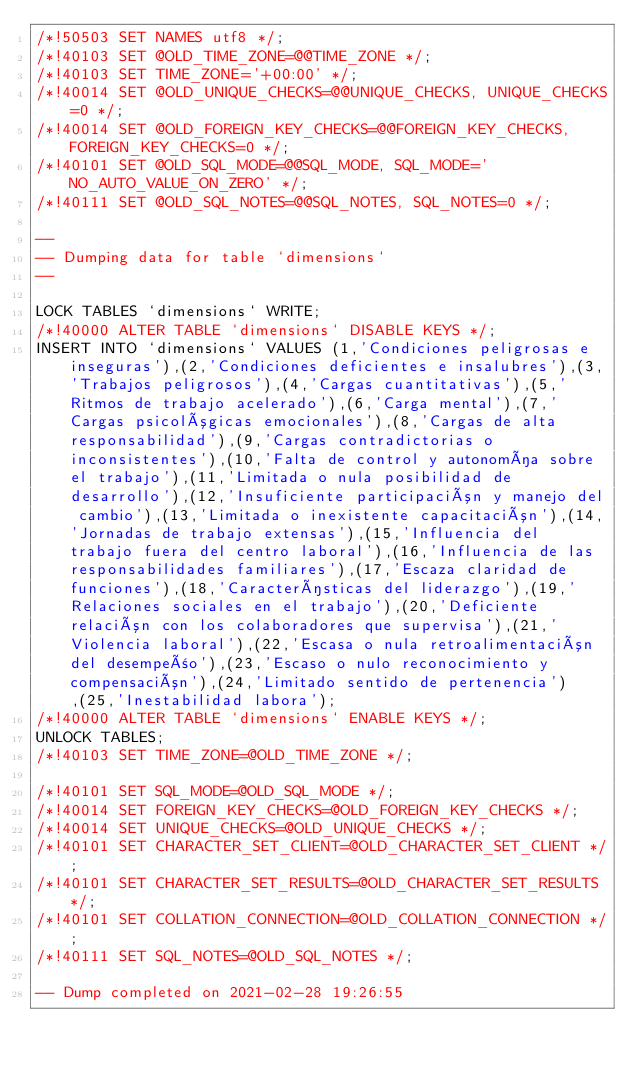<code> <loc_0><loc_0><loc_500><loc_500><_SQL_>/*!50503 SET NAMES utf8 */;
/*!40103 SET @OLD_TIME_ZONE=@@TIME_ZONE */;
/*!40103 SET TIME_ZONE='+00:00' */;
/*!40014 SET @OLD_UNIQUE_CHECKS=@@UNIQUE_CHECKS, UNIQUE_CHECKS=0 */;
/*!40014 SET @OLD_FOREIGN_KEY_CHECKS=@@FOREIGN_KEY_CHECKS, FOREIGN_KEY_CHECKS=0 */;
/*!40101 SET @OLD_SQL_MODE=@@SQL_MODE, SQL_MODE='NO_AUTO_VALUE_ON_ZERO' */;
/*!40111 SET @OLD_SQL_NOTES=@@SQL_NOTES, SQL_NOTES=0 */;

--
-- Dumping data for table `dimensions`
--

LOCK TABLES `dimensions` WRITE;
/*!40000 ALTER TABLE `dimensions` DISABLE KEYS */;
INSERT INTO `dimensions` VALUES (1,'Condiciones peligrosas e inseguras'),(2,'Condiciones deficientes e insalubres'),(3,'Trabajos peligrosos'),(4,'Cargas cuantitativas'),(5,'Ritmos de trabajo acelerado'),(6,'Carga mental'),(7,'Cargas psicológicas emocionales'),(8,'Cargas de alta responsabilidad'),(9,'Cargas contradictorias o inconsistentes'),(10,'Falta de control y autonomía sobre el trabajo'),(11,'Limitada o nula posibilidad de desarrollo'),(12,'Insuficiente participación y manejo del cambio'),(13,'Limitada o inexistente capacitación'),(14,'Jornadas de trabajo extensas'),(15,'Influencia del trabajo fuera del centro laboral'),(16,'Influencia de las responsabilidades familiares'),(17,'Escaza claridad de funciones'),(18,'Características del liderazgo'),(19,'Relaciones sociales en el trabajo'),(20,'Deficiente relación con los colaboradores que supervisa'),(21,'Violencia laboral'),(22,'Escasa o nula retroalimentación del desempeño'),(23,'Escaso o nulo reconocimiento y compensación'),(24,'Limitado sentido de pertenencia'),(25,'Inestabilidad labora');
/*!40000 ALTER TABLE `dimensions` ENABLE KEYS */;
UNLOCK TABLES;
/*!40103 SET TIME_ZONE=@OLD_TIME_ZONE */;

/*!40101 SET SQL_MODE=@OLD_SQL_MODE */;
/*!40014 SET FOREIGN_KEY_CHECKS=@OLD_FOREIGN_KEY_CHECKS */;
/*!40014 SET UNIQUE_CHECKS=@OLD_UNIQUE_CHECKS */;
/*!40101 SET CHARACTER_SET_CLIENT=@OLD_CHARACTER_SET_CLIENT */;
/*!40101 SET CHARACTER_SET_RESULTS=@OLD_CHARACTER_SET_RESULTS */;
/*!40101 SET COLLATION_CONNECTION=@OLD_COLLATION_CONNECTION */;
/*!40111 SET SQL_NOTES=@OLD_SQL_NOTES */;

-- Dump completed on 2021-02-28 19:26:55
</code> 